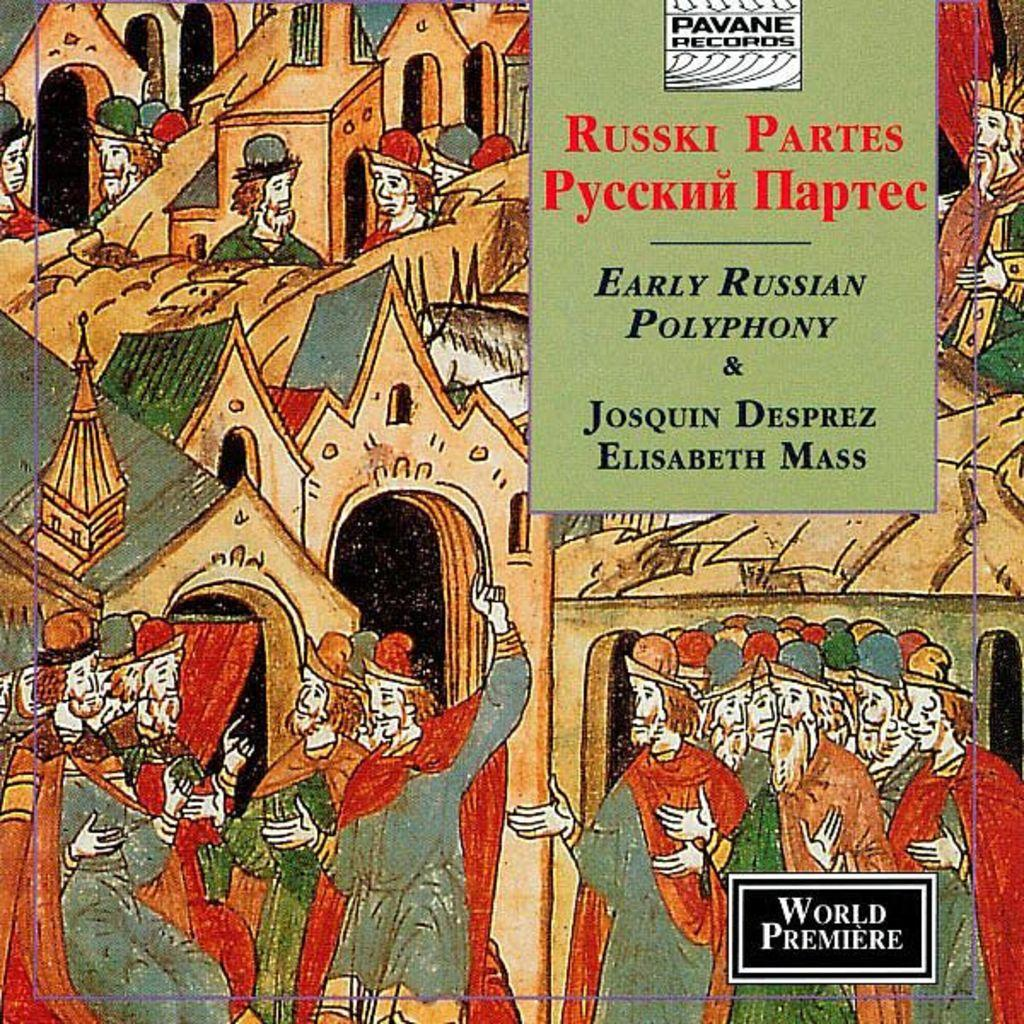<image>
Render a clear and concise summary of the photo. A book titled Early Russian Polyphony & Josquin Desperez Elisabeth Mass. 